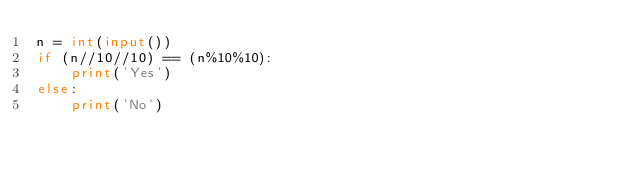<code> <loc_0><loc_0><loc_500><loc_500><_Python_>n = int(input())
if (n//10//10) == (n%10%10):
    print('Yes')
else:
    print('No')
</code> 